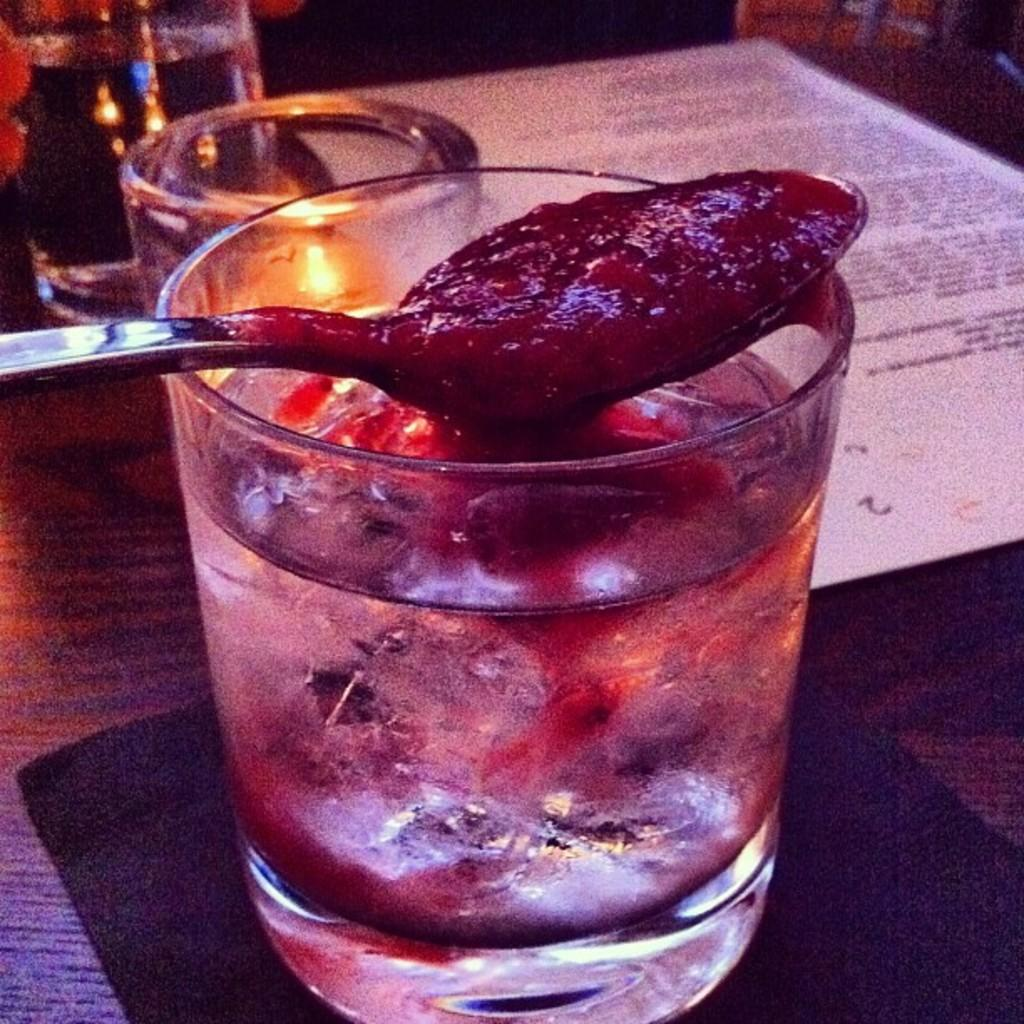What is in the glasses that are visible in the image? There are glasses with water in the image. What is the surface on which all the items are placed? All these items are placed on a mat in the image. What is the paper used for in the image? There is a paper in the image, which might be used for writing or drawing. What is the spoon holding in the image? There is a spoon with food in the image. Can you describe the background of the image? The background of the image is dark. How does the moon connect to the objects in the image? The moon is not present in the image, so it cannot be connected to the objects. Can you explain how the lift is used in the image? There is no lift present in the image, so it cannot be used. 